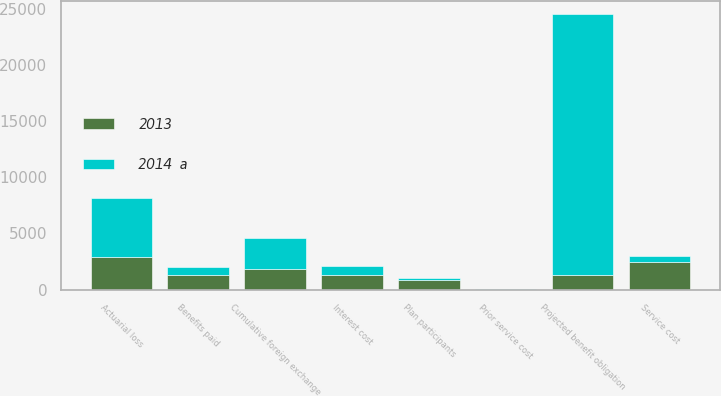<chart> <loc_0><loc_0><loc_500><loc_500><stacked_bar_chart><ecel><fcel>Projected benefit obligation<fcel>Cumulative foreign exchange<fcel>Service cost<fcel>Interest cost<fcel>Plan participants<fcel>Actuarial loss<fcel>Benefits paid<fcel>Prior service cost<nl><fcel>2014  a<fcel>23192<fcel>2822<fcel>591<fcel>796<fcel>180<fcel>5240<fcel>640<fcel>29<nl><fcel>2013<fcel>1285<fcel>1813<fcel>2450<fcel>1285<fcel>886<fcel>2952<fcel>1337<fcel>7<nl></chart> 